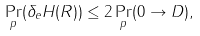<formula> <loc_0><loc_0><loc_500><loc_500>\Pr _ { p } ( \delta _ { e } H ( R ) ) \leq 2 \Pr _ { p } ( 0 \to D ) ,</formula> 